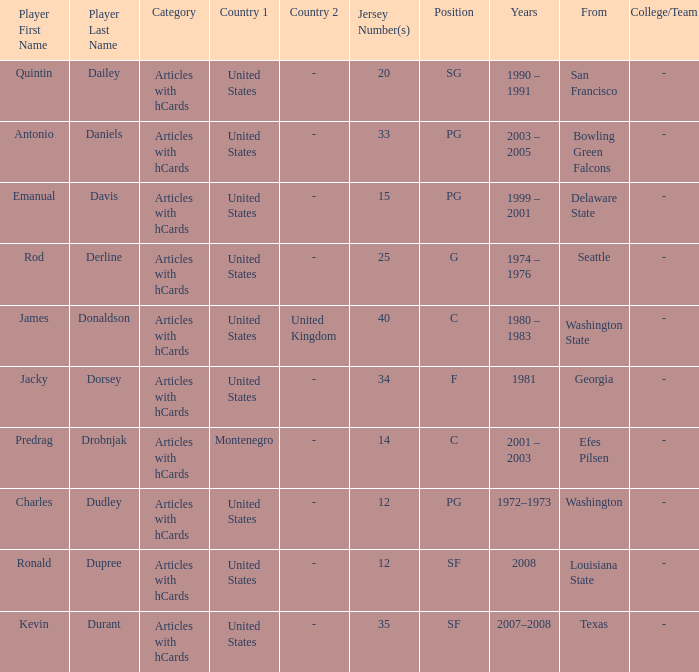What is the lowest jersey number of a player from louisiana state? 12.0. Would you be able to parse every entry in this table? {'header': ['Player First Name', 'Player Last Name', 'Category', 'Country 1', 'Country 2', 'Jersey Number(s)', 'Position', 'Years', 'From', 'College/Team'], 'rows': [['Quintin', 'Dailey', 'Articles with hCards', 'United States', '-', '20', 'SG', '1990 – 1991', 'San Francisco', '-'], ['Antonio', 'Daniels', 'Articles with hCards', 'United States', '-', '33', 'PG', '2003 – 2005', 'Bowling Green Falcons', '-'], ['Emanual', 'Davis', 'Articles with hCards', 'United States', '-', '15', 'PG', '1999 – 2001', 'Delaware State', '-'], ['Rod', 'Derline', 'Articles with hCards', 'United States', '-', '25', 'G', '1974 – 1976', 'Seattle', '-'], ['James', 'Donaldson', 'Articles with hCards', 'United States', 'United Kingdom', '40', 'C', '1980 – 1983', 'Washington State', '-'], ['Jacky', 'Dorsey', 'Articles with hCards', 'United States', '-', '34', 'F', '1981', 'Georgia', '-'], ['Predrag', 'Drobnjak', 'Articles with hCards', 'Montenegro', '-', '14', 'C', '2001 – 2003', 'Efes Pilsen', '-'], ['Charles', 'Dudley', 'Articles with hCards', 'United States', '-', '12', 'PG', '1972–1973', 'Washington', '-'], ['Ronald', 'Dupree', 'Articles with hCards', 'United States', '-', '12', 'SF', '2008', 'Louisiana State', '-'], ['Kevin', 'Durant', 'Articles with hCards', 'United States', '-', '35', 'SF', '2007–2008', 'Texas', '-']]} 